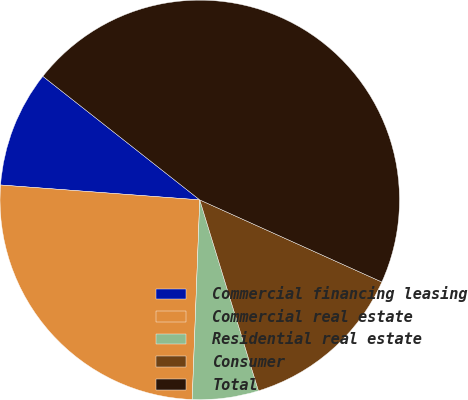Convert chart. <chart><loc_0><loc_0><loc_500><loc_500><pie_chart><fcel>Commercial financing leasing<fcel>Commercial real estate<fcel>Residential real estate<fcel>Consumer<fcel>Total<nl><fcel>9.43%<fcel>25.59%<fcel>5.35%<fcel>13.51%<fcel>46.13%<nl></chart> 